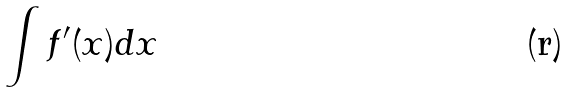<formula> <loc_0><loc_0><loc_500><loc_500>\int f ^ { \prime } ( x ) d x</formula> 